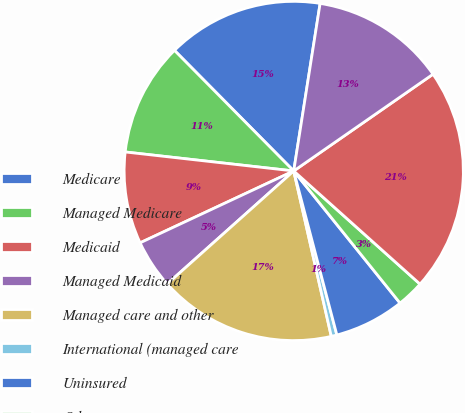<chart> <loc_0><loc_0><loc_500><loc_500><pie_chart><fcel>Medicare<fcel>Managed Medicare<fcel>Medicaid<fcel>Managed Medicaid<fcel>Managed care and other<fcel>International (managed care<fcel>Uninsured<fcel>Other<fcel>Revenues before provision for<fcel>Provision for doubtful<nl><fcel>14.9%<fcel>10.8%<fcel>8.75%<fcel>4.64%<fcel>16.95%<fcel>0.54%<fcel>6.69%<fcel>2.59%<fcel>21.29%<fcel>12.85%<nl></chart> 